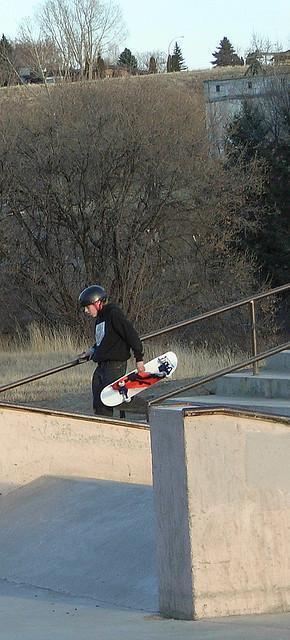How many black horse ?
Give a very brief answer. 0. 